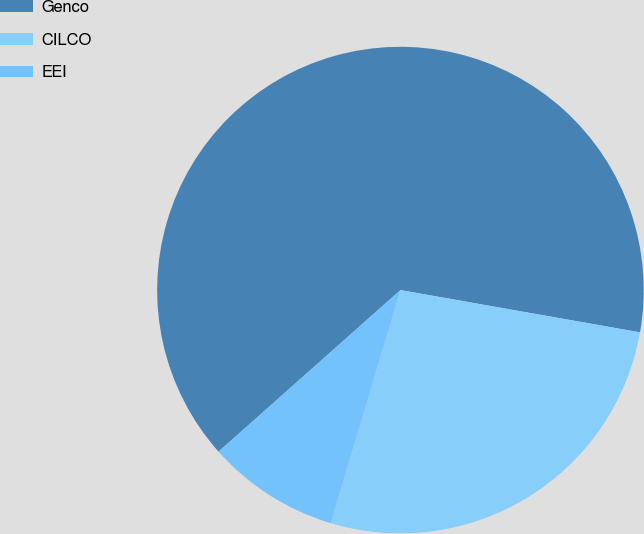<chart> <loc_0><loc_0><loc_500><loc_500><pie_chart><fcel>Genco<fcel>CILCO<fcel>EEI<nl><fcel>64.34%<fcel>26.84%<fcel>8.82%<nl></chart> 